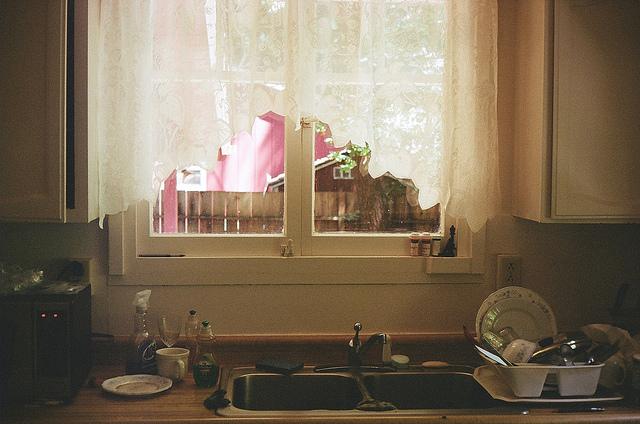What is seen outside the window?
Quick response, please. Trees. Is it night time in the picture?
Answer briefly. No. Where is the picture taken?
Short answer required. Kitchen. 